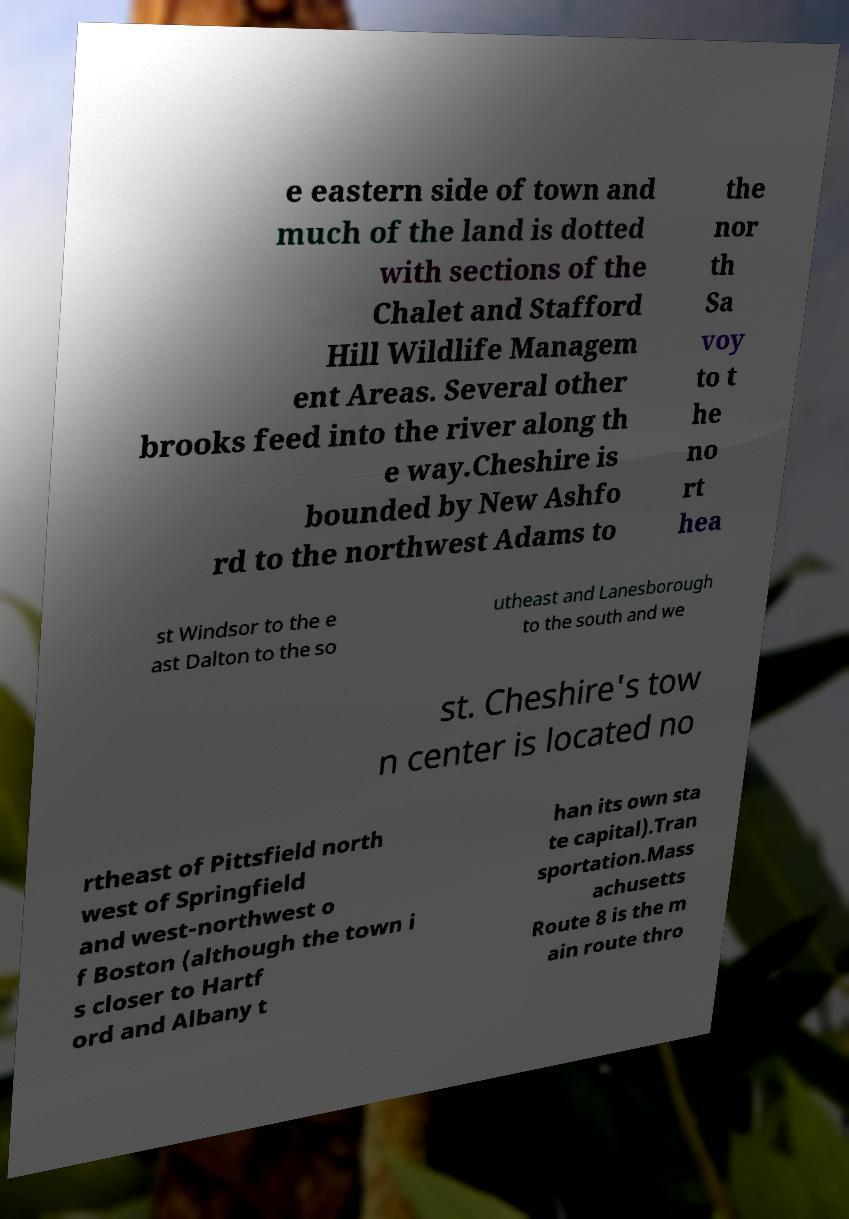Please read and relay the text visible in this image. What does it say? e eastern side of town and much of the land is dotted with sections of the Chalet and Stafford Hill Wildlife Managem ent Areas. Several other brooks feed into the river along th e way.Cheshire is bounded by New Ashfo rd to the northwest Adams to the nor th Sa voy to t he no rt hea st Windsor to the e ast Dalton to the so utheast and Lanesborough to the south and we st. Cheshire's tow n center is located no rtheast of Pittsfield north west of Springfield and west-northwest o f Boston (although the town i s closer to Hartf ord and Albany t han its own sta te capital).Tran sportation.Mass achusetts Route 8 is the m ain route thro 